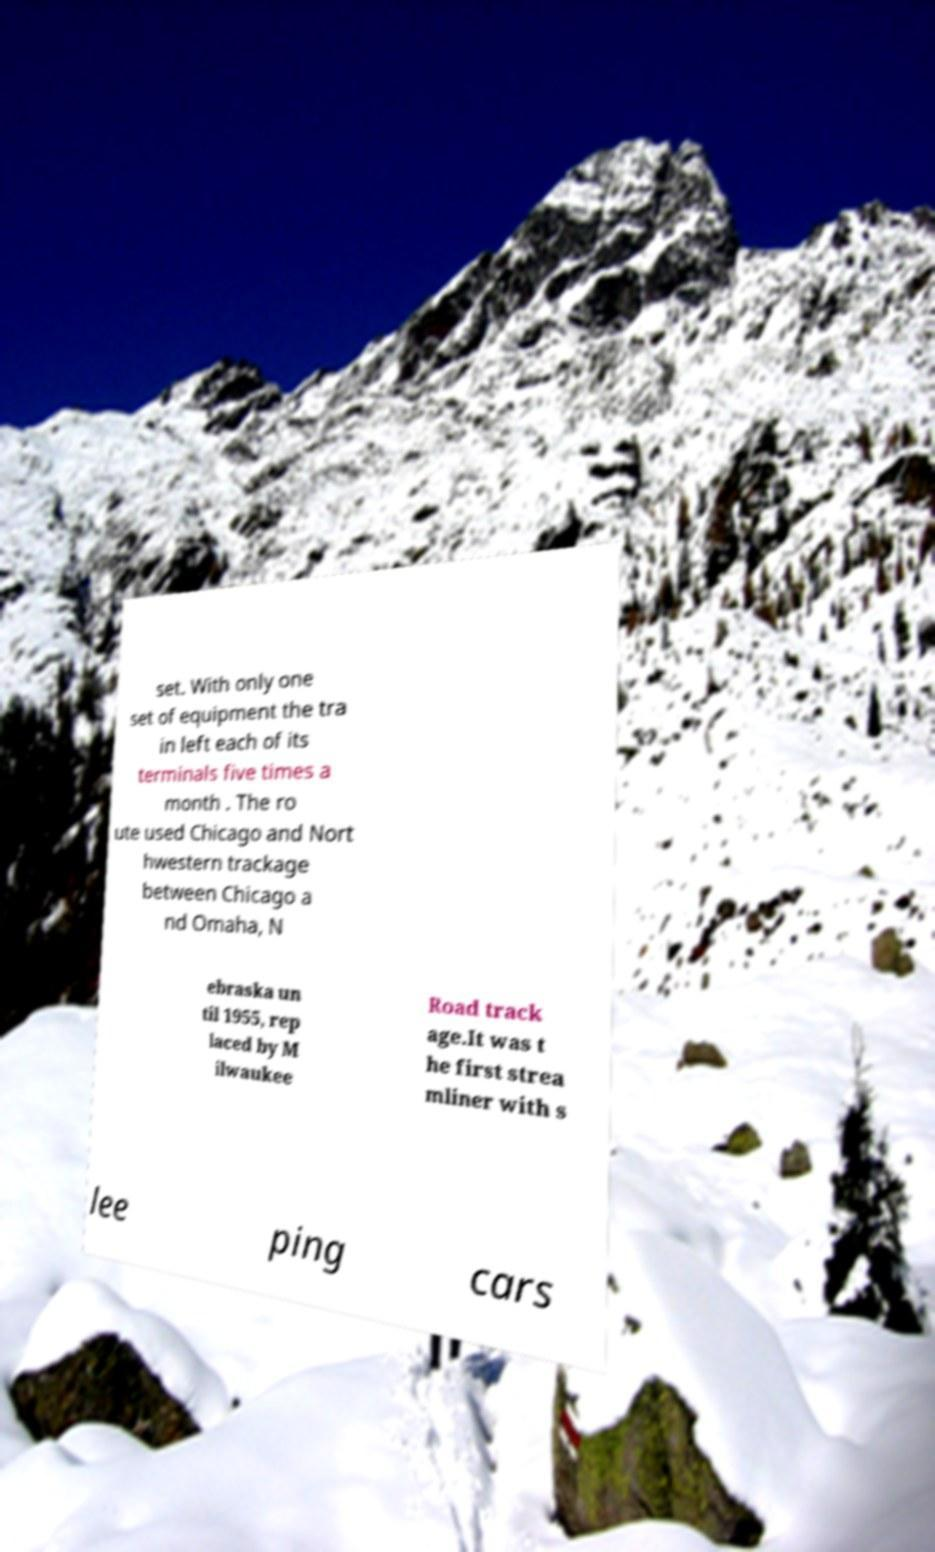I need the written content from this picture converted into text. Can you do that? set. With only one set of equipment the tra in left each of its terminals five times a month . The ro ute used Chicago and Nort hwestern trackage between Chicago a nd Omaha, N ebraska un til 1955, rep laced by M ilwaukee Road track age.It was t he first strea mliner with s lee ping cars 